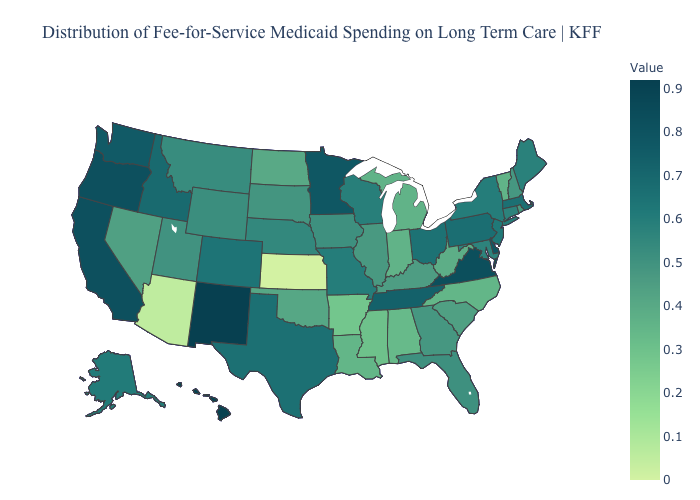Does Maine have the highest value in the Northeast?
Give a very brief answer. No. Among the states that border Oregon , which have the highest value?
Short answer required. California. Which states have the highest value in the USA?
Keep it brief. New Mexico. Which states have the highest value in the USA?
Answer briefly. New Mexico. 